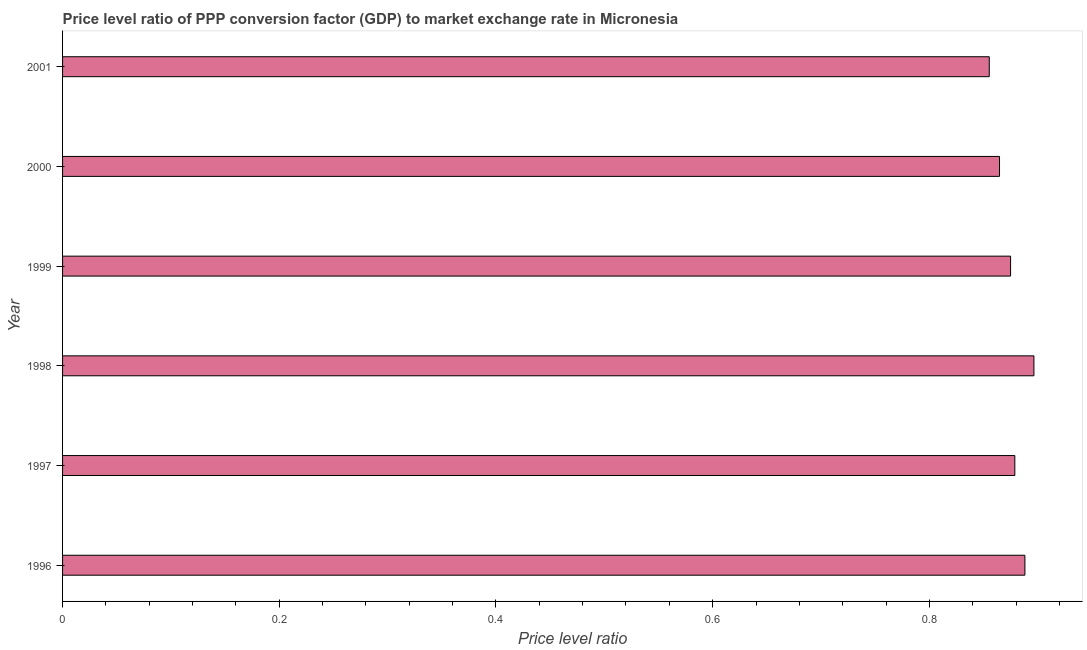Does the graph contain any zero values?
Offer a very short reply. No. Does the graph contain grids?
Offer a terse response. No. What is the title of the graph?
Make the answer very short. Price level ratio of PPP conversion factor (GDP) to market exchange rate in Micronesia. What is the label or title of the X-axis?
Offer a terse response. Price level ratio. What is the label or title of the Y-axis?
Ensure brevity in your answer.  Year. What is the price level ratio in 2001?
Offer a very short reply. 0.86. Across all years, what is the maximum price level ratio?
Ensure brevity in your answer.  0.9. Across all years, what is the minimum price level ratio?
Offer a very short reply. 0.86. What is the sum of the price level ratio?
Provide a short and direct response. 5.26. What is the difference between the price level ratio in 1997 and 2000?
Provide a succinct answer. 0.01. What is the average price level ratio per year?
Give a very brief answer. 0.88. What is the median price level ratio?
Offer a very short reply. 0.88. Do a majority of the years between 2000 and 2001 (inclusive) have price level ratio greater than 0.48 ?
Provide a short and direct response. Yes. What is the ratio of the price level ratio in 1996 to that in 2000?
Your answer should be compact. 1.03. Is the price level ratio in 1999 less than that in 2000?
Provide a short and direct response. No. What is the difference between the highest and the second highest price level ratio?
Your answer should be very brief. 0.01. What is the difference between the highest and the lowest price level ratio?
Give a very brief answer. 0.04. How many bars are there?
Offer a terse response. 6. How many years are there in the graph?
Provide a succinct answer. 6. What is the Price level ratio of 1996?
Ensure brevity in your answer.  0.89. What is the Price level ratio in 1997?
Give a very brief answer. 0.88. What is the Price level ratio in 1998?
Ensure brevity in your answer.  0.9. What is the Price level ratio of 1999?
Provide a short and direct response. 0.87. What is the Price level ratio of 2000?
Your answer should be compact. 0.86. What is the Price level ratio of 2001?
Provide a succinct answer. 0.86. What is the difference between the Price level ratio in 1996 and 1997?
Give a very brief answer. 0.01. What is the difference between the Price level ratio in 1996 and 1998?
Keep it short and to the point. -0.01. What is the difference between the Price level ratio in 1996 and 1999?
Provide a short and direct response. 0.01. What is the difference between the Price level ratio in 1996 and 2000?
Make the answer very short. 0.02. What is the difference between the Price level ratio in 1996 and 2001?
Your response must be concise. 0.03. What is the difference between the Price level ratio in 1997 and 1998?
Make the answer very short. -0.02. What is the difference between the Price level ratio in 1997 and 1999?
Your answer should be compact. 0. What is the difference between the Price level ratio in 1997 and 2000?
Make the answer very short. 0.01. What is the difference between the Price level ratio in 1997 and 2001?
Your response must be concise. 0.02. What is the difference between the Price level ratio in 1998 and 1999?
Give a very brief answer. 0.02. What is the difference between the Price level ratio in 1998 and 2000?
Keep it short and to the point. 0.03. What is the difference between the Price level ratio in 1998 and 2001?
Your answer should be compact. 0.04. What is the difference between the Price level ratio in 1999 and 2000?
Offer a terse response. 0.01. What is the difference between the Price level ratio in 1999 and 2001?
Ensure brevity in your answer.  0.02. What is the difference between the Price level ratio in 2000 and 2001?
Offer a very short reply. 0.01. What is the ratio of the Price level ratio in 1996 to that in 1998?
Make the answer very short. 0.99. What is the ratio of the Price level ratio in 1996 to that in 2001?
Your response must be concise. 1.04. What is the ratio of the Price level ratio in 1997 to that in 1998?
Make the answer very short. 0.98. What is the ratio of the Price level ratio in 1997 to that in 1999?
Your response must be concise. 1. What is the ratio of the Price level ratio in 1997 to that in 2001?
Give a very brief answer. 1.03. What is the ratio of the Price level ratio in 1998 to that in 2000?
Provide a succinct answer. 1.04. What is the ratio of the Price level ratio in 1998 to that in 2001?
Keep it short and to the point. 1.05. What is the ratio of the Price level ratio in 1999 to that in 2000?
Offer a very short reply. 1.01. 